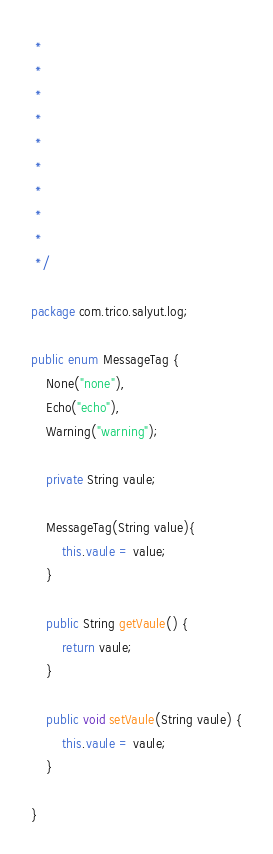<code> <loc_0><loc_0><loc_500><loc_500><_Java_> *
 *
 *
 *
 *
 *
 *
 *
 *
 */

package com.trico.salyut.log;

public enum MessageTag {
	None("none"),
	Echo("echo"),
	Warning("warning");
	
	private String vaule;
	
	MessageTag(String value){
		this.vaule = value;
	}

	public String getVaule() {
		return vaule;
	}

	public void setVaule(String vaule) {
		this.vaule = vaule;
	}
	
}
</code> 